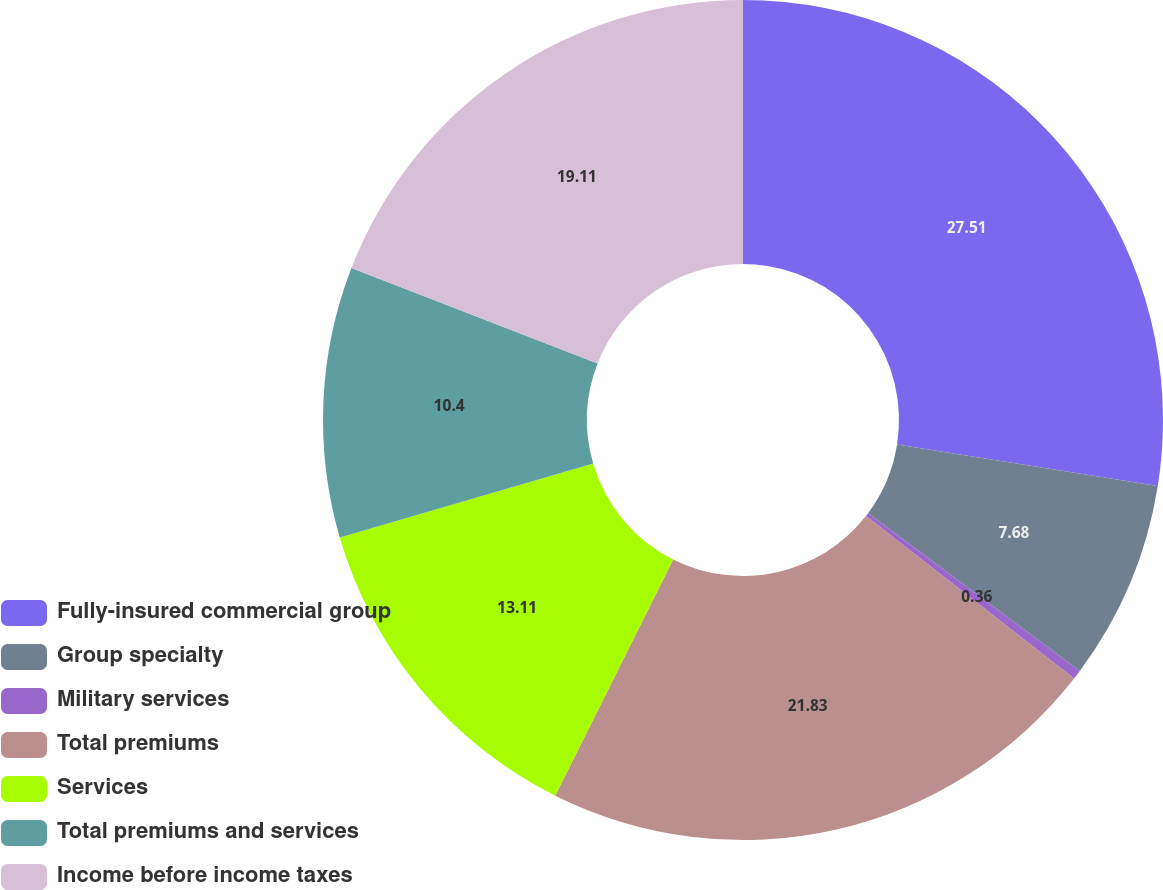Convert chart to OTSL. <chart><loc_0><loc_0><loc_500><loc_500><pie_chart><fcel>Fully-insured commercial group<fcel>Group specialty<fcel>Military services<fcel>Total premiums<fcel>Services<fcel>Total premiums and services<fcel>Income before income taxes<nl><fcel>27.51%<fcel>7.68%<fcel>0.36%<fcel>21.83%<fcel>13.11%<fcel>10.4%<fcel>19.11%<nl></chart> 